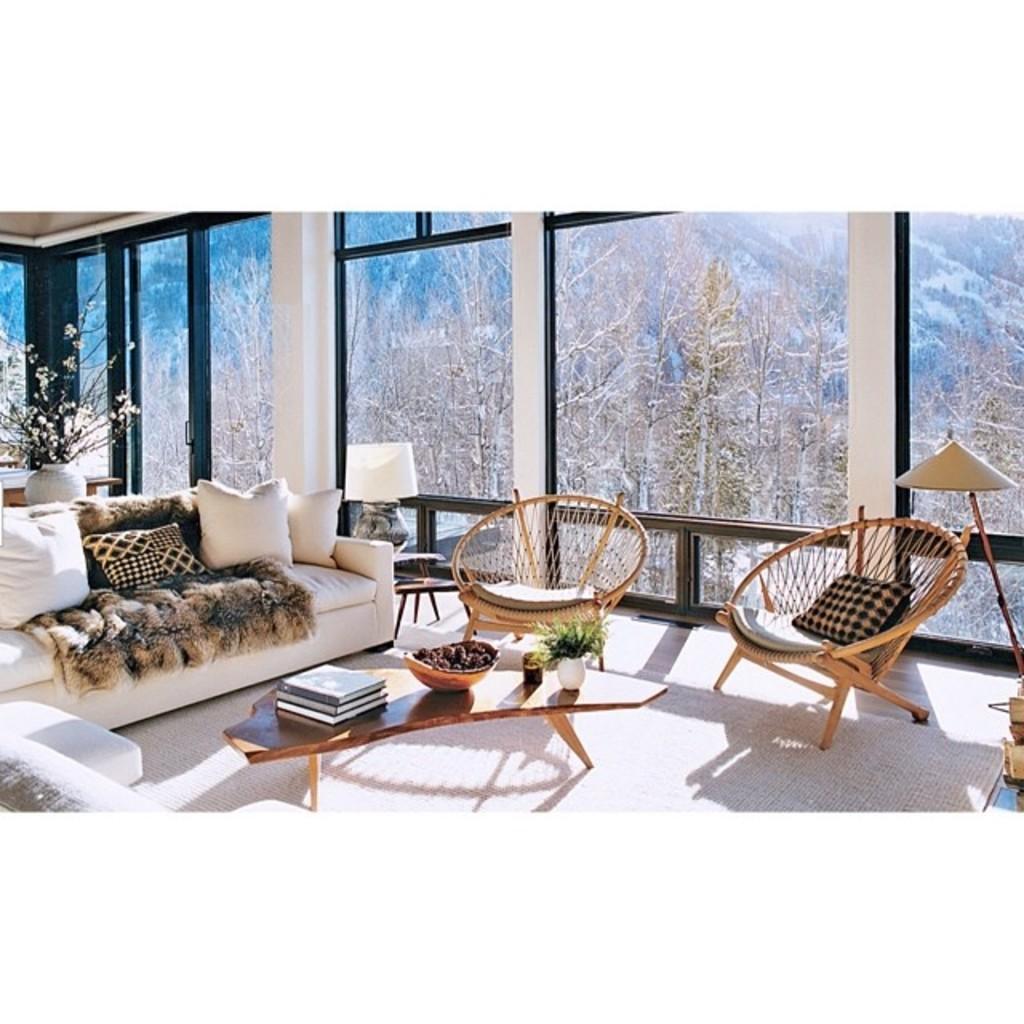Please provide a concise description of this image. A picture inside of a room. These are chairs. This is a couch with pillows. Beside this couch there is a plant. Outside of this window there are bare trees. On this table there is a bowl, books and plant. 